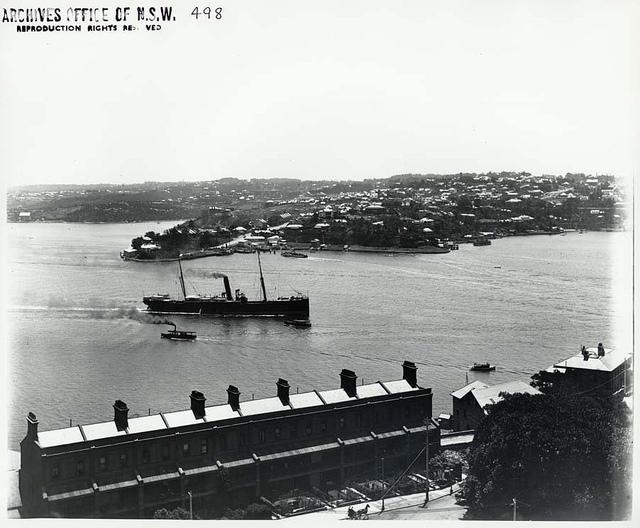Are there any steamboats in the water?
Quick response, please. Yes. What era is this photo from?
Be succinct. 1900's. Is the wind blowing to the right or to the left?
Answer briefly. Left. 